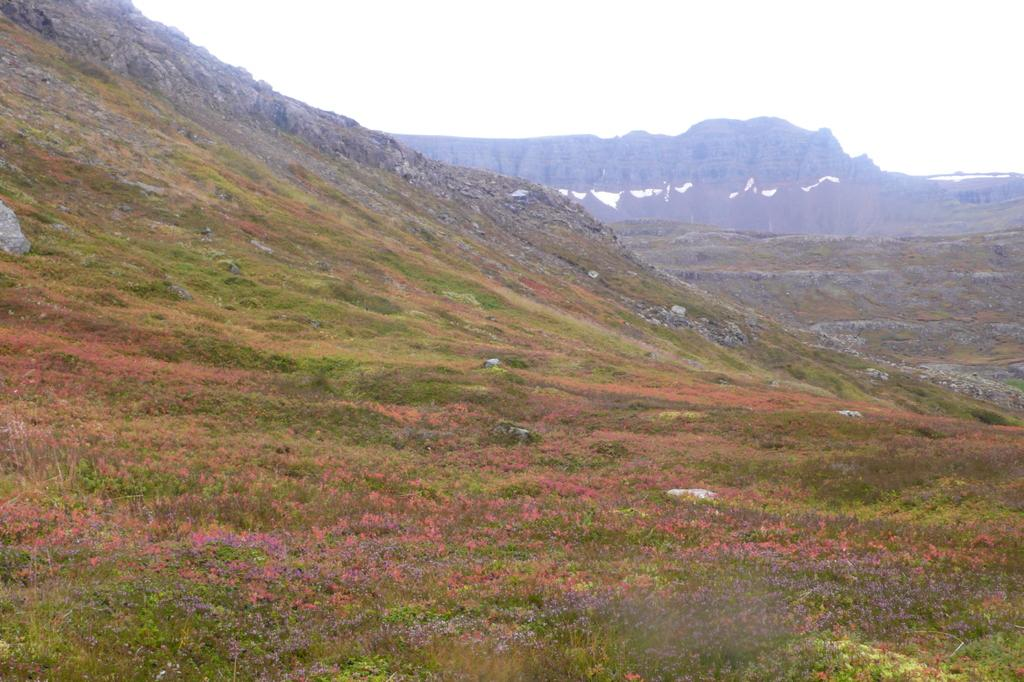What type of natural landscape is depicted in the image? The image features mountains. What other natural elements can be seen in the image? There are plants and trees in the image. How would you describe the sky in the image? The sky is clear in the image. What type of coat is the mountain wearing in the image? Mountains do not wear coats, as they are inanimate objects. 